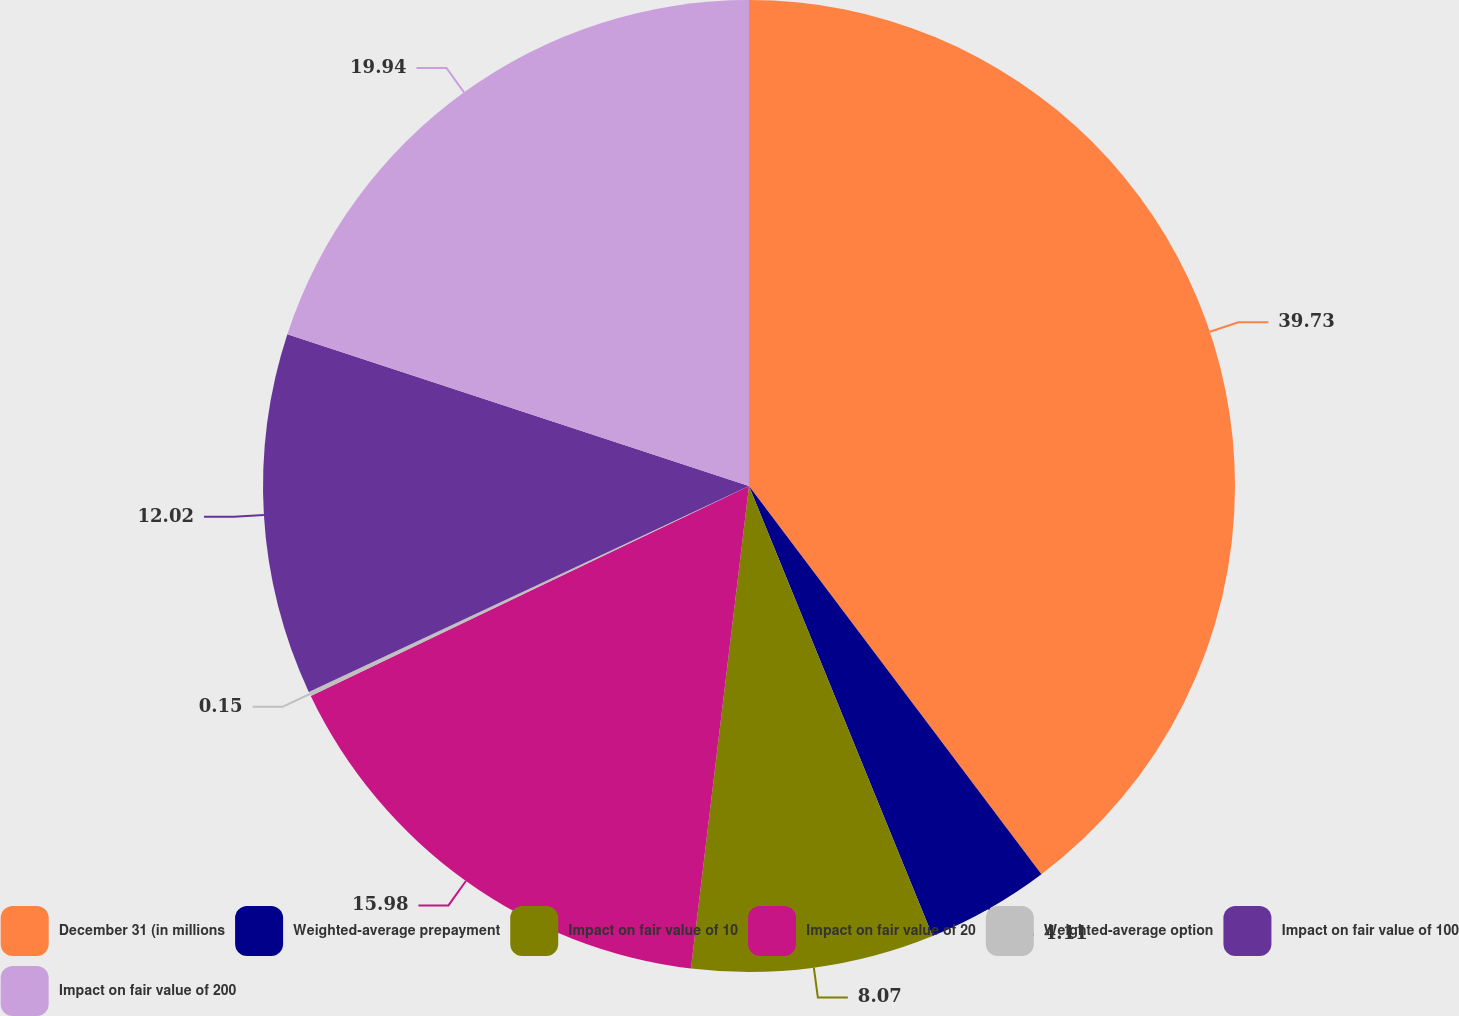Convert chart to OTSL. <chart><loc_0><loc_0><loc_500><loc_500><pie_chart><fcel>December 31 (in millions<fcel>Weighted-average prepayment<fcel>Impact on fair value of 10<fcel>Impact on fair value of 20<fcel>Weighted-average option<fcel>Impact on fair value of 100<fcel>Impact on fair value of 200<nl><fcel>39.72%<fcel>4.11%<fcel>8.07%<fcel>15.98%<fcel>0.15%<fcel>12.02%<fcel>19.94%<nl></chart> 